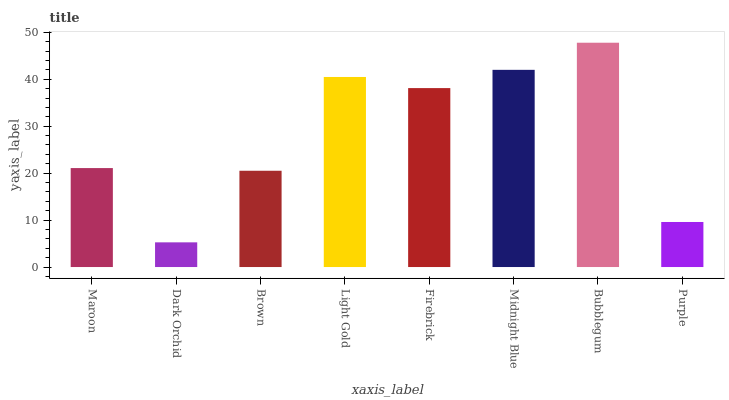Is Brown the minimum?
Answer yes or no. No. Is Brown the maximum?
Answer yes or no. No. Is Brown greater than Dark Orchid?
Answer yes or no. Yes. Is Dark Orchid less than Brown?
Answer yes or no. Yes. Is Dark Orchid greater than Brown?
Answer yes or no. No. Is Brown less than Dark Orchid?
Answer yes or no. No. Is Firebrick the high median?
Answer yes or no. Yes. Is Maroon the low median?
Answer yes or no. Yes. Is Dark Orchid the high median?
Answer yes or no. No. Is Light Gold the low median?
Answer yes or no. No. 